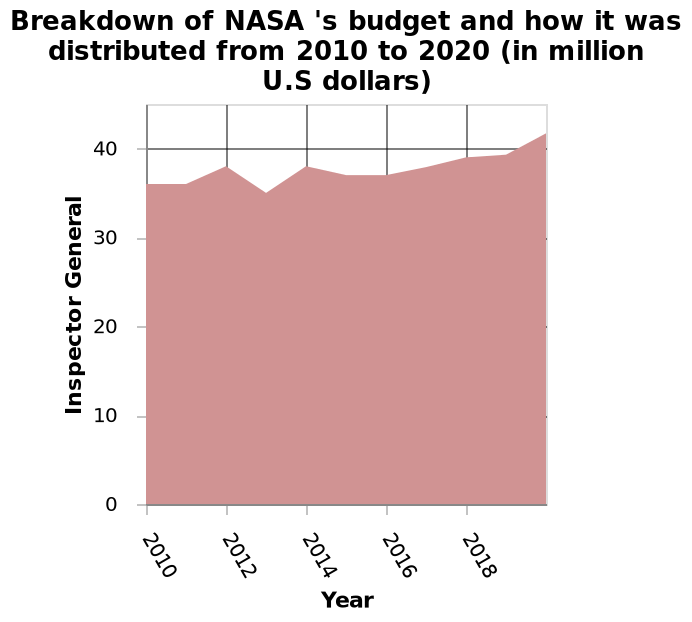<image>
In which year did the highest increase in the number of Inspector General occur? The year with the highest increase in the number of Inspector General is unknown based on the provided information. By how much did the number of Inspector General increase from 2010 to 2020? The number of Inspector General increased by approximately 5 million from 2010 to 2020. What does the area chart show the breakdown of? The area chart shows the breakdown of NASA's budget and how it was distributed from 2010 to 2020. Does the area chart show the breakdown of NASA's budget and how it was distributed from 2010 to 2021? No.The area chart shows the breakdown of NASA's budget and how it was distributed from 2010 to 2020. 